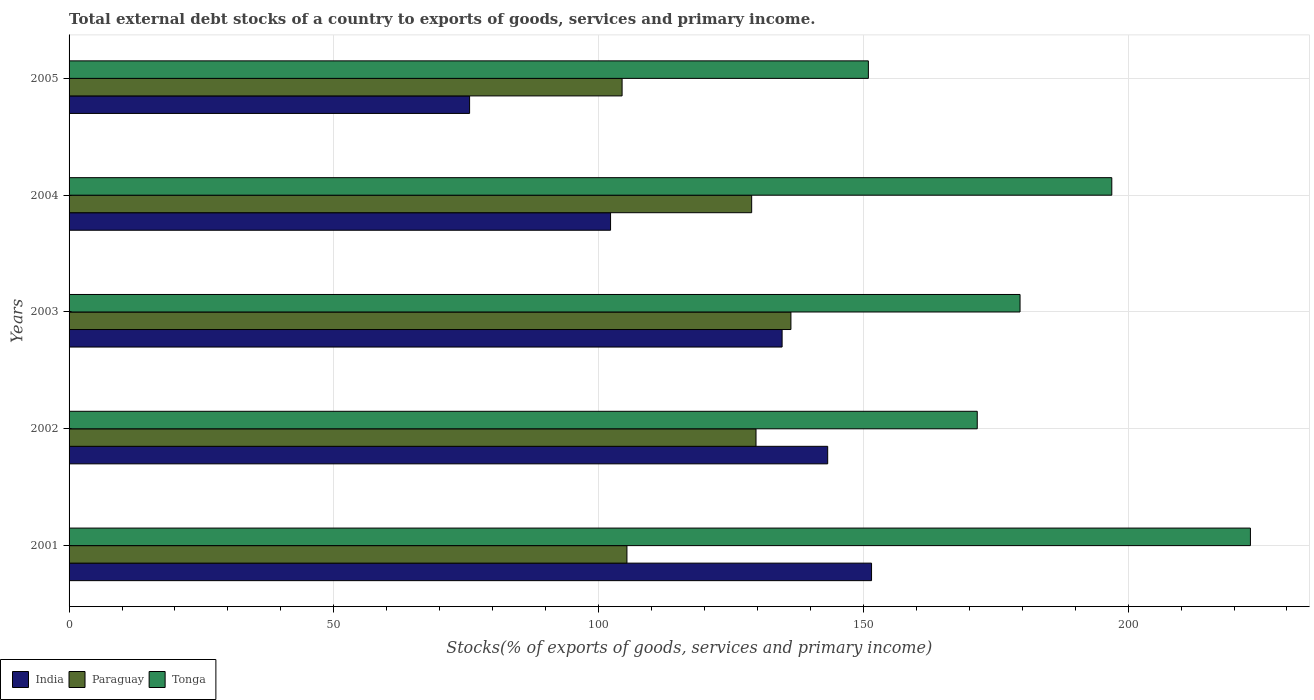How many groups of bars are there?
Your answer should be very brief. 5. Are the number of bars on each tick of the Y-axis equal?
Your answer should be very brief. Yes. How many bars are there on the 1st tick from the bottom?
Give a very brief answer. 3. In how many cases, is the number of bars for a given year not equal to the number of legend labels?
Offer a terse response. 0. What is the total debt stocks in Paraguay in 2001?
Your response must be concise. 105.35. Across all years, what is the maximum total debt stocks in India?
Provide a short and direct response. 151.55. Across all years, what is the minimum total debt stocks in Tonga?
Keep it short and to the point. 150.95. In which year was the total debt stocks in Paraguay maximum?
Give a very brief answer. 2003. In which year was the total debt stocks in Tonga minimum?
Your response must be concise. 2005. What is the total total debt stocks in India in the graph?
Offer a very short reply. 607.38. What is the difference between the total debt stocks in India in 2001 and that in 2005?
Your answer should be compact. 75.91. What is the difference between the total debt stocks in Paraguay in 2001 and the total debt stocks in Tonga in 2002?
Provide a short and direct response. -66.16. What is the average total debt stocks in Paraguay per year?
Ensure brevity in your answer.  120.95. In the year 2002, what is the difference between the total debt stocks in Tonga and total debt stocks in India?
Keep it short and to the point. 28.25. What is the ratio of the total debt stocks in Paraguay in 2002 to that in 2003?
Your answer should be very brief. 0.95. Is the difference between the total debt stocks in Tonga in 2001 and 2003 greater than the difference between the total debt stocks in India in 2001 and 2003?
Provide a succinct answer. Yes. What is the difference between the highest and the second highest total debt stocks in Paraguay?
Offer a terse response. 6.59. What is the difference between the highest and the lowest total debt stocks in Tonga?
Offer a terse response. 72.15. What does the 1st bar from the top in 2005 represents?
Give a very brief answer. Tonga. What does the 2nd bar from the bottom in 2002 represents?
Make the answer very short. Paraguay. What is the difference between two consecutive major ticks on the X-axis?
Make the answer very short. 50. Where does the legend appear in the graph?
Make the answer very short. Bottom left. How many legend labels are there?
Your response must be concise. 3. How are the legend labels stacked?
Ensure brevity in your answer.  Horizontal. What is the title of the graph?
Give a very brief answer. Total external debt stocks of a country to exports of goods, services and primary income. What is the label or title of the X-axis?
Make the answer very short. Stocks(% of exports of goods, services and primary income). What is the Stocks(% of exports of goods, services and primary income) in India in 2001?
Provide a succinct answer. 151.55. What is the Stocks(% of exports of goods, services and primary income) in Paraguay in 2001?
Provide a short and direct response. 105.35. What is the Stocks(% of exports of goods, services and primary income) of Tonga in 2001?
Ensure brevity in your answer.  223.1. What is the Stocks(% of exports of goods, services and primary income) in India in 2002?
Your answer should be compact. 143.27. What is the Stocks(% of exports of goods, services and primary income) in Paraguay in 2002?
Provide a short and direct response. 129.73. What is the Stocks(% of exports of goods, services and primary income) of Tonga in 2002?
Offer a terse response. 171.51. What is the Stocks(% of exports of goods, services and primary income) of India in 2003?
Make the answer very short. 134.66. What is the Stocks(% of exports of goods, services and primary income) in Paraguay in 2003?
Provide a short and direct response. 136.32. What is the Stocks(% of exports of goods, services and primary income) in Tonga in 2003?
Offer a very short reply. 179.6. What is the Stocks(% of exports of goods, services and primary income) of India in 2004?
Keep it short and to the point. 102.26. What is the Stocks(% of exports of goods, services and primary income) of Paraguay in 2004?
Your answer should be compact. 128.91. What is the Stocks(% of exports of goods, services and primary income) in Tonga in 2004?
Give a very brief answer. 196.92. What is the Stocks(% of exports of goods, services and primary income) of India in 2005?
Your response must be concise. 75.64. What is the Stocks(% of exports of goods, services and primary income) of Paraguay in 2005?
Your answer should be very brief. 104.44. What is the Stocks(% of exports of goods, services and primary income) in Tonga in 2005?
Keep it short and to the point. 150.95. Across all years, what is the maximum Stocks(% of exports of goods, services and primary income) in India?
Give a very brief answer. 151.55. Across all years, what is the maximum Stocks(% of exports of goods, services and primary income) in Paraguay?
Provide a short and direct response. 136.32. Across all years, what is the maximum Stocks(% of exports of goods, services and primary income) of Tonga?
Your answer should be compact. 223.1. Across all years, what is the minimum Stocks(% of exports of goods, services and primary income) in India?
Provide a succinct answer. 75.64. Across all years, what is the minimum Stocks(% of exports of goods, services and primary income) of Paraguay?
Give a very brief answer. 104.44. Across all years, what is the minimum Stocks(% of exports of goods, services and primary income) in Tonga?
Make the answer very short. 150.95. What is the total Stocks(% of exports of goods, services and primary income) in India in the graph?
Your answer should be compact. 607.38. What is the total Stocks(% of exports of goods, services and primary income) of Paraguay in the graph?
Your answer should be compact. 604.76. What is the total Stocks(% of exports of goods, services and primary income) of Tonga in the graph?
Provide a short and direct response. 922.08. What is the difference between the Stocks(% of exports of goods, services and primary income) of India in 2001 and that in 2002?
Provide a succinct answer. 8.28. What is the difference between the Stocks(% of exports of goods, services and primary income) in Paraguay in 2001 and that in 2002?
Your response must be concise. -24.38. What is the difference between the Stocks(% of exports of goods, services and primary income) in Tonga in 2001 and that in 2002?
Your answer should be compact. 51.59. What is the difference between the Stocks(% of exports of goods, services and primary income) of India in 2001 and that in 2003?
Keep it short and to the point. 16.89. What is the difference between the Stocks(% of exports of goods, services and primary income) in Paraguay in 2001 and that in 2003?
Offer a very short reply. -30.97. What is the difference between the Stocks(% of exports of goods, services and primary income) of Tonga in 2001 and that in 2003?
Your answer should be compact. 43.51. What is the difference between the Stocks(% of exports of goods, services and primary income) of India in 2001 and that in 2004?
Make the answer very short. 49.29. What is the difference between the Stocks(% of exports of goods, services and primary income) of Paraguay in 2001 and that in 2004?
Your response must be concise. -23.56. What is the difference between the Stocks(% of exports of goods, services and primary income) in Tonga in 2001 and that in 2004?
Your response must be concise. 26.18. What is the difference between the Stocks(% of exports of goods, services and primary income) of India in 2001 and that in 2005?
Your answer should be compact. 75.91. What is the difference between the Stocks(% of exports of goods, services and primary income) in Paraguay in 2001 and that in 2005?
Offer a very short reply. 0.92. What is the difference between the Stocks(% of exports of goods, services and primary income) in Tonga in 2001 and that in 2005?
Give a very brief answer. 72.15. What is the difference between the Stocks(% of exports of goods, services and primary income) in India in 2002 and that in 2003?
Give a very brief answer. 8.61. What is the difference between the Stocks(% of exports of goods, services and primary income) of Paraguay in 2002 and that in 2003?
Ensure brevity in your answer.  -6.59. What is the difference between the Stocks(% of exports of goods, services and primary income) of Tonga in 2002 and that in 2003?
Ensure brevity in your answer.  -8.08. What is the difference between the Stocks(% of exports of goods, services and primary income) in India in 2002 and that in 2004?
Provide a succinct answer. 41. What is the difference between the Stocks(% of exports of goods, services and primary income) of Paraguay in 2002 and that in 2004?
Provide a short and direct response. 0.82. What is the difference between the Stocks(% of exports of goods, services and primary income) in Tonga in 2002 and that in 2004?
Offer a very short reply. -25.41. What is the difference between the Stocks(% of exports of goods, services and primary income) of India in 2002 and that in 2005?
Offer a terse response. 67.63. What is the difference between the Stocks(% of exports of goods, services and primary income) in Paraguay in 2002 and that in 2005?
Your response must be concise. 25.29. What is the difference between the Stocks(% of exports of goods, services and primary income) in Tonga in 2002 and that in 2005?
Provide a succinct answer. 20.56. What is the difference between the Stocks(% of exports of goods, services and primary income) in India in 2003 and that in 2004?
Your answer should be very brief. 32.4. What is the difference between the Stocks(% of exports of goods, services and primary income) of Paraguay in 2003 and that in 2004?
Offer a very short reply. 7.41. What is the difference between the Stocks(% of exports of goods, services and primary income) in Tonga in 2003 and that in 2004?
Your answer should be compact. -17.33. What is the difference between the Stocks(% of exports of goods, services and primary income) of India in 2003 and that in 2005?
Keep it short and to the point. 59.02. What is the difference between the Stocks(% of exports of goods, services and primary income) in Paraguay in 2003 and that in 2005?
Give a very brief answer. 31.89. What is the difference between the Stocks(% of exports of goods, services and primary income) in Tonga in 2003 and that in 2005?
Provide a short and direct response. 28.64. What is the difference between the Stocks(% of exports of goods, services and primary income) in India in 2004 and that in 2005?
Your answer should be very brief. 26.62. What is the difference between the Stocks(% of exports of goods, services and primary income) in Paraguay in 2004 and that in 2005?
Provide a short and direct response. 24.47. What is the difference between the Stocks(% of exports of goods, services and primary income) of Tonga in 2004 and that in 2005?
Ensure brevity in your answer.  45.97. What is the difference between the Stocks(% of exports of goods, services and primary income) of India in 2001 and the Stocks(% of exports of goods, services and primary income) of Paraguay in 2002?
Make the answer very short. 21.82. What is the difference between the Stocks(% of exports of goods, services and primary income) of India in 2001 and the Stocks(% of exports of goods, services and primary income) of Tonga in 2002?
Your answer should be compact. -19.96. What is the difference between the Stocks(% of exports of goods, services and primary income) of Paraguay in 2001 and the Stocks(% of exports of goods, services and primary income) of Tonga in 2002?
Ensure brevity in your answer.  -66.16. What is the difference between the Stocks(% of exports of goods, services and primary income) of India in 2001 and the Stocks(% of exports of goods, services and primary income) of Paraguay in 2003?
Offer a terse response. 15.23. What is the difference between the Stocks(% of exports of goods, services and primary income) of India in 2001 and the Stocks(% of exports of goods, services and primary income) of Tonga in 2003?
Give a very brief answer. -28.05. What is the difference between the Stocks(% of exports of goods, services and primary income) of Paraguay in 2001 and the Stocks(% of exports of goods, services and primary income) of Tonga in 2003?
Provide a short and direct response. -74.24. What is the difference between the Stocks(% of exports of goods, services and primary income) in India in 2001 and the Stocks(% of exports of goods, services and primary income) in Paraguay in 2004?
Provide a short and direct response. 22.64. What is the difference between the Stocks(% of exports of goods, services and primary income) of India in 2001 and the Stocks(% of exports of goods, services and primary income) of Tonga in 2004?
Your response must be concise. -45.37. What is the difference between the Stocks(% of exports of goods, services and primary income) in Paraguay in 2001 and the Stocks(% of exports of goods, services and primary income) in Tonga in 2004?
Provide a short and direct response. -91.57. What is the difference between the Stocks(% of exports of goods, services and primary income) of India in 2001 and the Stocks(% of exports of goods, services and primary income) of Paraguay in 2005?
Provide a short and direct response. 47.11. What is the difference between the Stocks(% of exports of goods, services and primary income) of India in 2001 and the Stocks(% of exports of goods, services and primary income) of Tonga in 2005?
Give a very brief answer. 0.6. What is the difference between the Stocks(% of exports of goods, services and primary income) of Paraguay in 2001 and the Stocks(% of exports of goods, services and primary income) of Tonga in 2005?
Offer a terse response. -45.6. What is the difference between the Stocks(% of exports of goods, services and primary income) of India in 2002 and the Stocks(% of exports of goods, services and primary income) of Paraguay in 2003?
Provide a short and direct response. 6.94. What is the difference between the Stocks(% of exports of goods, services and primary income) of India in 2002 and the Stocks(% of exports of goods, services and primary income) of Tonga in 2003?
Make the answer very short. -36.33. What is the difference between the Stocks(% of exports of goods, services and primary income) in Paraguay in 2002 and the Stocks(% of exports of goods, services and primary income) in Tonga in 2003?
Keep it short and to the point. -49.86. What is the difference between the Stocks(% of exports of goods, services and primary income) of India in 2002 and the Stocks(% of exports of goods, services and primary income) of Paraguay in 2004?
Make the answer very short. 14.36. What is the difference between the Stocks(% of exports of goods, services and primary income) in India in 2002 and the Stocks(% of exports of goods, services and primary income) in Tonga in 2004?
Ensure brevity in your answer.  -53.65. What is the difference between the Stocks(% of exports of goods, services and primary income) in Paraguay in 2002 and the Stocks(% of exports of goods, services and primary income) in Tonga in 2004?
Keep it short and to the point. -67.19. What is the difference between the Stocks(% of exports of goods, services and primary income) of India in 2002 and the Stocks(% of exports of goods, services and primary income) of Paraguay in 2005?
Keep it short and to the point. 38.83. What is the difference between the Stocks(% of exports of goods, services and primary income) in India in 2002 and the Stocks(% of exports of goods, services and primary income) in Tonga in 2005?
Keep it short and to the point. -7.69. What is the difference between the Stocks(% of exports of goods, services and primary income) of Paraguay in 2002 and the Stocks(% of exports of goods, services and primary income) of Tonga in 2005?
Your answer should be very brief. -21.22. What is the difference between the Stocks(% of exports of goods, services and primary income) of India in 2003 and the Stocks(% of exports of goods, services and primary income) of Paraguay in 2004?
Your answer should be very brief. 5.75. What is the difference between the Stocks(% of exports of goods, services and primary income) of India in 2003 and the Stocks(% of exports of goods, services and primary income) of Tonga in 2004?
Provide a succinct answer. -62.26. What is the difference between the Stocks(% of exports of goods, services and primary income) of Paraguay in 2003 and the Stocks(% of exports of goods, services and primary income) of Tonga in 2004?
Your answer should be compact. -60.6. What is the difference between the Stocks(% of exports of goods, services and primary income) in India in 2003 and the Stocks(% of exports of goods, services and primary income) in Paraguay in 2005?
Offer a very short reply. 30.22. What is the difference between the Stocks(% of exports of goods, services and primary income) in India in 2003 and the Stocks(% of exports of goods, services and primary income) in Tonga in 2005?
Make the answer very short. -16.29. What is the difference between the Stocks(% of exports of goods, services and primary income) in Paraguay in 2003 and the Stocks(% of exports of goods, services and primary income) in Tonga in 2005?
Give a very brief answer. -14.63. What is the difference between the Stocks(% of exports of goods, services and primary income) in India in 2004 and the Stocks(% of exports of goods, services and primary income) in Paraguay in 2005?
Offer a very short reply. -2.18. What is the difference between the Stocks(% of exports of goods, services and primary income) in India in 2004 and the Stocks(% of exports of goods, services and primary income) in Tonga in 2005?
Give a very brief answer. -48.69. What is the difference between the Stocks(% of exports of goods, services and primary income) of Paraguay in 2004 and the Stocks(% of exports of goods, services and primary income) of Tonga in 2005?
Your response must be concise. -22.04. What is the average Stocks(% of exports of goods, services and primary income) in India per year?
Your response must be concise. 121.48. What is the average Stocks(% of exports of goods, services and primary income) in Paraguay per year?
Your response must be concise. 120.95. What is the average Stocks(% of exports of goods, services and primary income) of Tonga per year?
Ensure brevity in your answer.  184.42. In the year 2001, what is the difference between the Stocks(% of exports of goods, services and primary income) of India and Stocks(% of exports of goods, services and primary income) of Paraguay?
Offer a terse response. 46.2. In the year 2001, what is the difference between the Stocks(% of exports of goods, services and primary income) in India and Stocks(% of exports of goods, services and primary income) in Tonga?
Give a very brief answer. -71.55. In the year 2001, what is the difference between the Stocks(% of exports of goods, services and primary income) in Paraguay and Stocks(% of exports of goods, services and primary income) in Tonga?
Make the answer very short. -117.75. In the year 2002, what is the difference between the Stocks(% of exports of goods, services and primary income) in India and Stocks(% of exports of goods, services and primary income) in Paraguay?
Your answer should be compact. 13.54. In the year 2002, what is the difference between the Stocks(% of exports of goods, services and primary income) of India and Stocks(% of exports of goods, services and primary income) of Tonga?
Your answer should be very brief. -28.25. In the year 2002, what is the difference between the Stocks(% of exports of goods, services and primary income) in Paraguay and Stocks(% of exports of goods, services and primary income) in Tonga?
Your response must be concise. -41.78. In the year 2003, what is the difference between the Stocks(% of exports of goods, services and primary income) in India and Stocks(% of exports of goods, services and primary income) in Paraguay?
Offer a terse response. -1.66. In the year 2003, what is the difference between the Stocks(% of exports of goods, services and primary income) in India and Stocks(% of exports of goods, services and primary income) in Tonga?
Offer a very short reply. -44.94. In the year 2003, what is the difference between the Stocks(% of exports of goods, services and primary income) of Paraguay and Stocks(% of exports of goods, services and primary income) of Tonga?
Give a very brief answer. -43.27. In the year 2004, what is the difference between the Stocks(% of exports of goods, services and primary income) of India and Stocks(% of exports of goods, services and primary income) of Paraguay?
Provide a succinct answer. -26.65. In the year 2004, what is the difference between the Stocks(% of exports of goods, services and primary income) of India and Stocks(% of exports of goods, services and primary income) of Tonga?
Offer a very short reply. -94.66. In the year 2004, what is the difference between the Stocks(% of exports of goods, services and primary income) in Paraguay and Stocks(% of exports of goods, services and primary income) in Tonga?
Your answer should be very brief. -68.01. In the year 2005, what is the difference between the Stocks(% of exports of goods, services and primary income) of India and Stocks(% of exports of goods, services and primary income) of Paraguay?
Your answer should be very brief. -28.8. In the year 2005, what is the difference between the Stocks(% of exports of goods, services and primary income) in India and Stocks(% of exports of goods, services and primary income) in Tonga?
Make the answer very short. -75.31. In the year 2005, what is the difference between the Stocks(% of exports of goods, services and primary income) in Paraguay and Stocks(% of exports of goods, services and primary income) in Tonga?
Make the answer very short. -46.51. What is the ratio of the Stocks(% of exports of goods, services and primary income) in India in 2001 to that in 2002?
Ensure brevity in your answer.  1.06. What is the ratio of the Stocks(% of exports of goods, services and primary income) in Paraguay in 2001 to that in 2002?
Your answer should be compact. 0.81. What is the ratio of the Stocks(% of exports of goods, services and primary income) in Tonga in 2001 to that in 2002?
Keep it short and to the point. 1.3. What is the ratio of the Stocks(% of exports of goods, services and primary income) in India in 2001 to that in 2003?
Keep it short and to the point. 1.13. What is the ratio of the Stocks(% of exports of goods, services and primary income) of Paraguay in 2001 to that in 2003?
Your answer should be compact. 0.77. What is the ratio of the Stocks(% of exports of goods, services and primary income) of Tonga in 2001 to that in 2003?
Your answer should be very brief. 1.24. What is the ratio of the Stocks(% of exports of goods, services and primary income) of India in 2001 to that in 2004?
Offer a terse response. 1.48. What is the ratio of the Stocks(% of exports of goods, services and primary income) of Paraguay in 2001 to that in 2004?
Your answer should be compact. 0.82. What is the ratio of the Stocks(% of exports of goods, services and primary income) in Tonga in 2001 to that in 2004?
Your answer should be very brief. 1.13. What is the ratio of the Stocks(% of exports of goods, services and primary income) of India in 2001 to that in 2005?
Your answer should be very brief. 2. What is the ratio of the Stocks(% of exports of goods, services and primary income) of Paraguay in 2001 to that in 2005?
Give a very brief answer. 1.01. What is the ratio of the Stocks(% of exports of goods, services and primary income) of Tonga in 2001 to that in 2005?
Offer a very short reply. 1.48. What is the ratio of the Stocks(% of exports of goods, services and primary income) of India in 2002 to that in 2003?
Your response must be concise. 1.06. What is the ratio of the Stocks(% of exports of goods, services and primary income) of Paraguay in 2002 to that in 2003?
Give a very brief answer. 0.95. What is the ratio of the Stocks(% of exports of goods, services and primary income) of Tonga in 2002 to that in 2003?
Offer a very short reply. 0.95. What is the ratio of the Stocks(% of exports of goods, services and primary income) in India in 2002 to that in 2004?
Make the answer very short. 1.4. What is the ratio of the Stocks(% of exports of goods, services and primary income) of Paraguay in 2002 to that in 2004?
Your answer should be compact. 1.01. What is the ratio of the Stocks(% of exports of goods, services and primary income) of Tonga in 2002 to that in 2004?
Offer a terse response. 0.87. What is the ratio of the Stocks(% of exports of goods, services and primary income) of India in 2002 to that in 2005?
Offer a terse response. 1.89. What is the ratio of the Stocks(% of exports of goods, services and primary income) in Paraguay in 2002 to that in 2005?
Your answer should be compact. 1.24. What is the ratio of the Stocks(% of exports of goods, services and primary income) of Tonga in 2002 to that in 2005?
Offer a terse response. 1.14. What is the ratio of the Stocks(% of exports of goods, services and primary income) of India in 2003 to that in 2004?
Provide a succinct answer. 1.32. What is the ratio of the Stocks(% of exports of goods, services and primary income) of Paraguay in 2003 to that in 2004?
Offer a terse response. 1.06. What is the ratio of the Stocks(% of exports of goods, services and primary income) in Tonga in 2003 to that in 2004?
Ensure brevity in your answer.  0.91. What is the ratio of the Stocks(% of exports of goods, services and primary income) in India in 2003 to that in 2005?
Provide a short and direct response. 1.78. What is the ratio of the Stocks(% of exports of goods, services and primary income) in Paraguay in 2003 to that in 2005?
Your response must be concise. 1.31. What is the ratio of the Stocks(% of exports of goods, services and primary income) of Tonga in 2003 to that in 2005?
Provide a short and direct response. 1.19. What is the ratio of the Stocks(% of exports of goods, services and primary income) in India in 2004 to that in 2005?
Give a very brief answer. 1.35. What is the ratio of the Stocks(% of exports of goods, services and primary income) in Paraguay in 2004 to that in 2005?
Keep it short and to the point. 1.23. What is the ratio of the Stocks(% of exports of goods, services and primary income) of Tonga in 2004 to that in 2005?
Give a very brief answer. 1.3. What is the difference between the highest and the second highest Stocks(% of exports of goods, services and primary income) in India?
Offer a terse response. 8.28. What is the difference between the highest and the second highest Stocks(% of exports of goods, services and primary income) in Paraguay?
Make the answer very short. 6.59. What is the difference between the highest and the second highest Stocks(% of exports of goods, services and primary income) in Tonga?
Ensure brevity in your answer.  26.18. What is the difference between the highest and the lowest Stocks(% of exports of goods, services and primary income) of India?
Your answer should be very brief. 75.91. What is the difference between the highest and the lowest Stocks(% of exports of goods, services and primary income) in Paraguay?
Ensure brevity in your answer.  31.89. What is the difference between the highest and the lowest Stocks(% of exports of goods, services and primary income) in Tonga?
Your answer should be very brief. 72.15. 